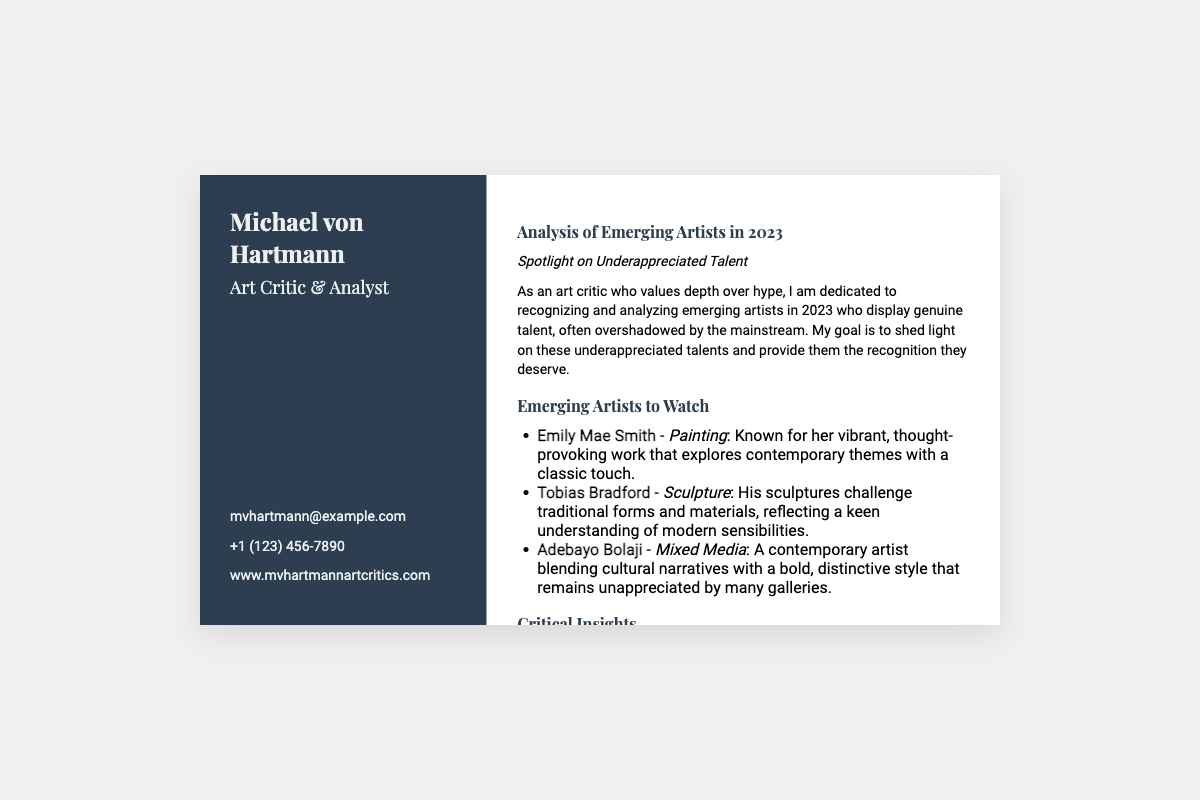What is the name of the art critic? The name of the art critic is prominently displayed at the top of the document.
Answer: Michael von Hartmann What is the email address provided? The email address is listed in the contact information section.
Answer: mvhartmann@example.com How many emerging artists are mentioned? The document explicitly lists three emerging artists under the section "Emerging Artists to Watch."
Answer: 3 What type of art does Emily Mae Smith specialize in? Emily Mae Smith's specialization is specifically noted in her description.
Answer: Painting Who does the document compare emerging artists to? The document makes a comparison in order to elevate the emerging artists, specifically naming the artist deemed overrated.
Answer: Paul Delvaux What is the primary focus of the analysis in 2023? The focus of the analysis is clearly defined at the beginning of the section.
Answer: Underappreciated Talent What is Tobias Bradford's art medium? His specialization is mentioned in the list of emerging artists.
Answer: Sculpture What is the main goal of the critic according to the document? The document states the goal of the critic early on, emphasizing recognition and analysis.
Answer: Provide recognition What type of document is this? The structure and content indicate a specific type of document in the arts community.
Answer: Business card 